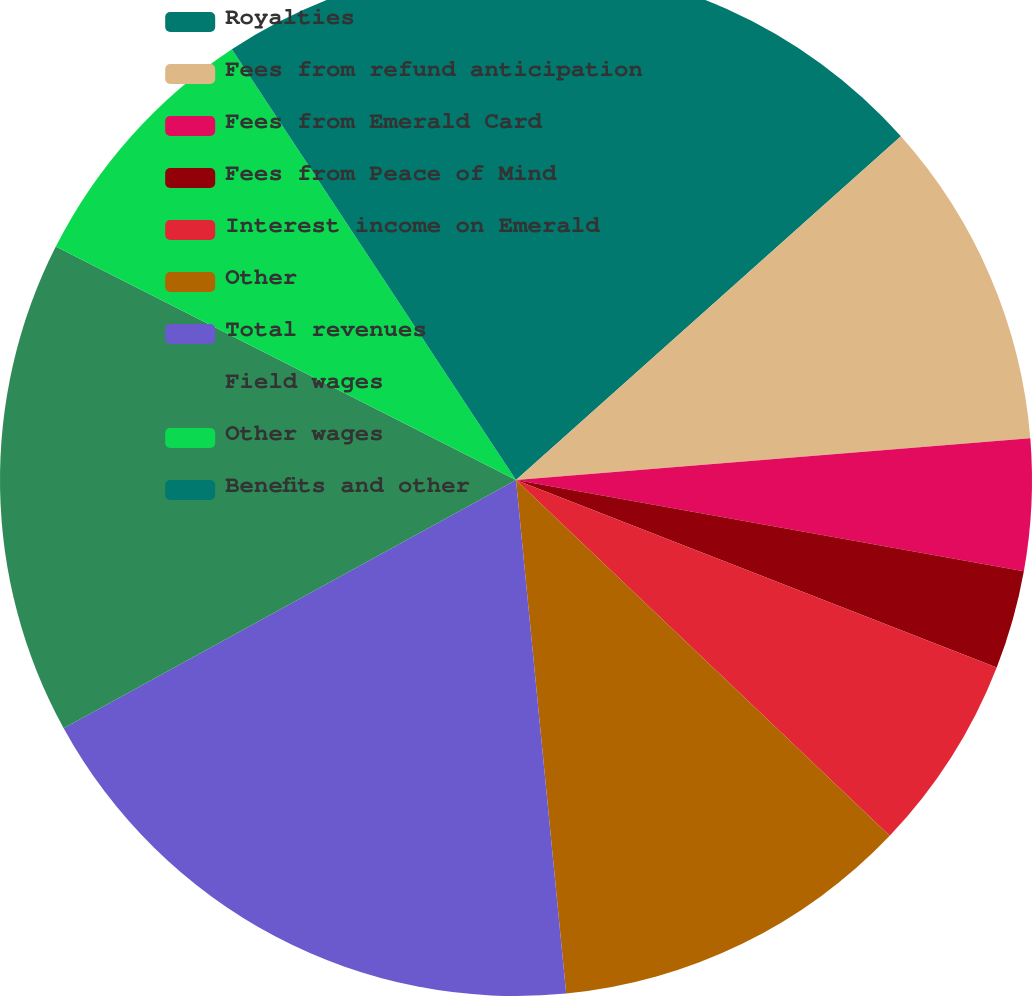Convert chart. <chart><loc_0><loc_0><loc_500><loc_500><pie_chart><fcel>Royalties<fcel>Fees from refund anticipation<fcel>Fees from Emerald Card<fcel>Fees from Peace of Mind<fcel>Interest income on Emerald<fcel>Other<fcel>Total revenues<fcel>Field wages<fcel>Other wages<fcel>Benefits and other<nl><fcel>13.4%<fcel>10.31%<fcel>4.12%<fcel>3.09%<fcel>6.19%<fcel>11.34%<fcel>18.56%<fcel>15.46%<fcel>8.25%<fcel>9.28%<nl></chart> 